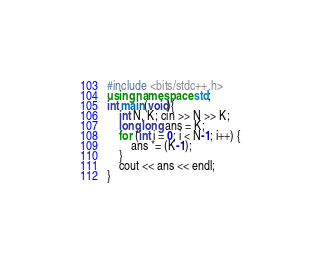<code> <loc_0><loc_0><loc_500><loc_500><_C++_>#include <bits/stdc++.h>
using namespace std;
int main(void){
    int N, K; cin >> N >> K;
    long long ans = K;
    for (int i = 0; i < N-1; i++) {
        ans *= (K-1);
    }
    cout << ans << endl;
}
</code> 